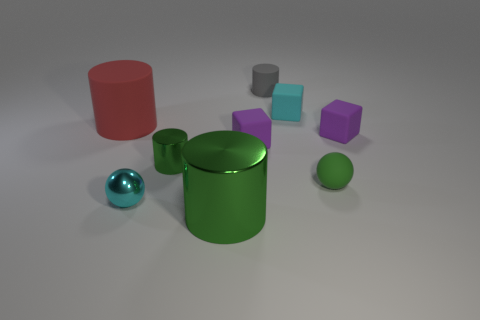Subtract all tiny matte cylinders. How many cylinders are left? 3 Subtract all blue cubes. How many green cylinders are left? 2 Subtract 1 blocks. How many blocks are left? 2 Subtract all red cylinders. How many cylinders are left? 3 Subtract all cyan cylinders. Subtract all purple spheres. How many cylinders are left? 4 Subtract all blocks. How many objects are left? 6 Add 2 tiny green cylinders. How many tiny green cylinders exist? 3 Subtract 1 red cylinders. How many objects are left? 8 Subtract all small shiny cylinders. Subtract all small brown cylinders. How many objects are left? 8 Add 5 red rubber cylinders. How many red rubber cylinders are left? 6 